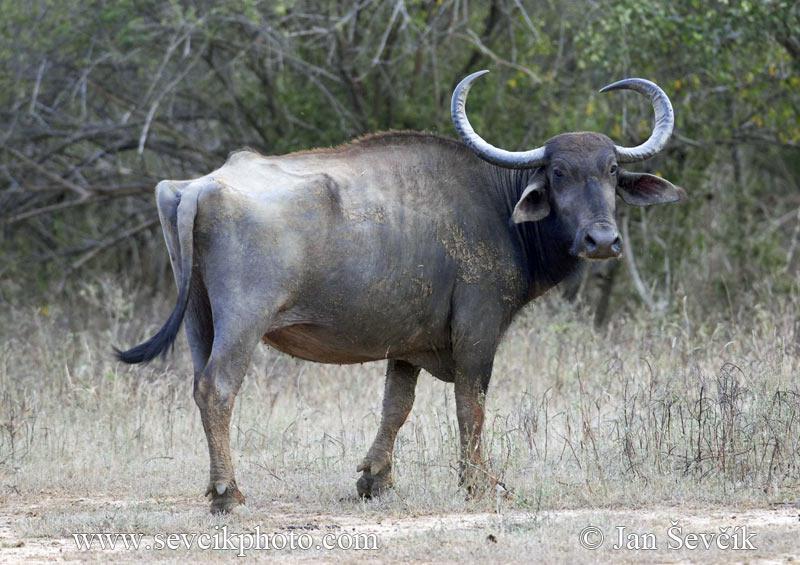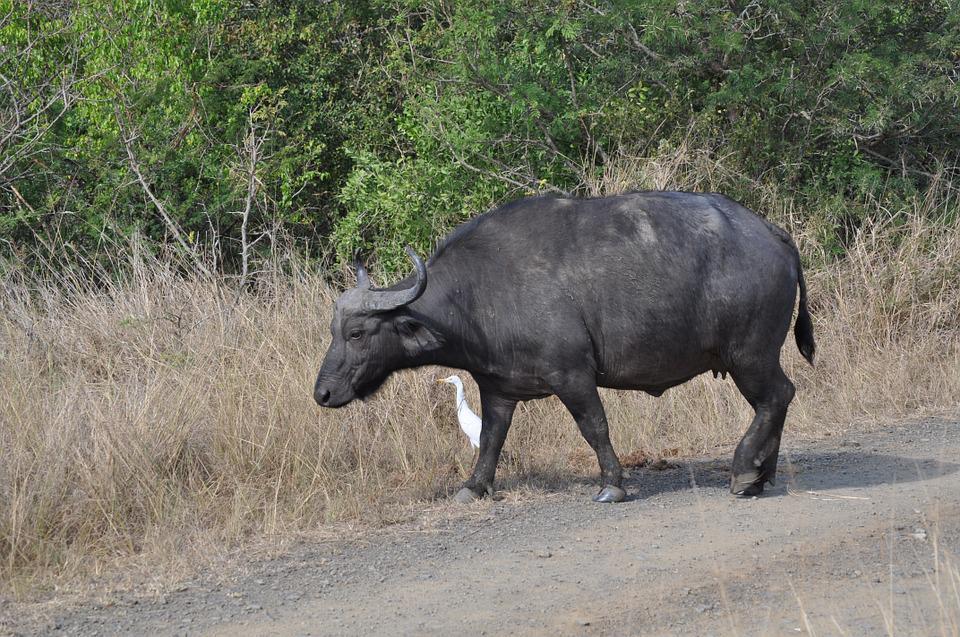The first image is the image on the left, the second image is the image on the right. For the images displayed, is the sentence "The oxen in the foreground of the two images have their bodies facing each other." factually correct? Answer yes or no. Yes. 